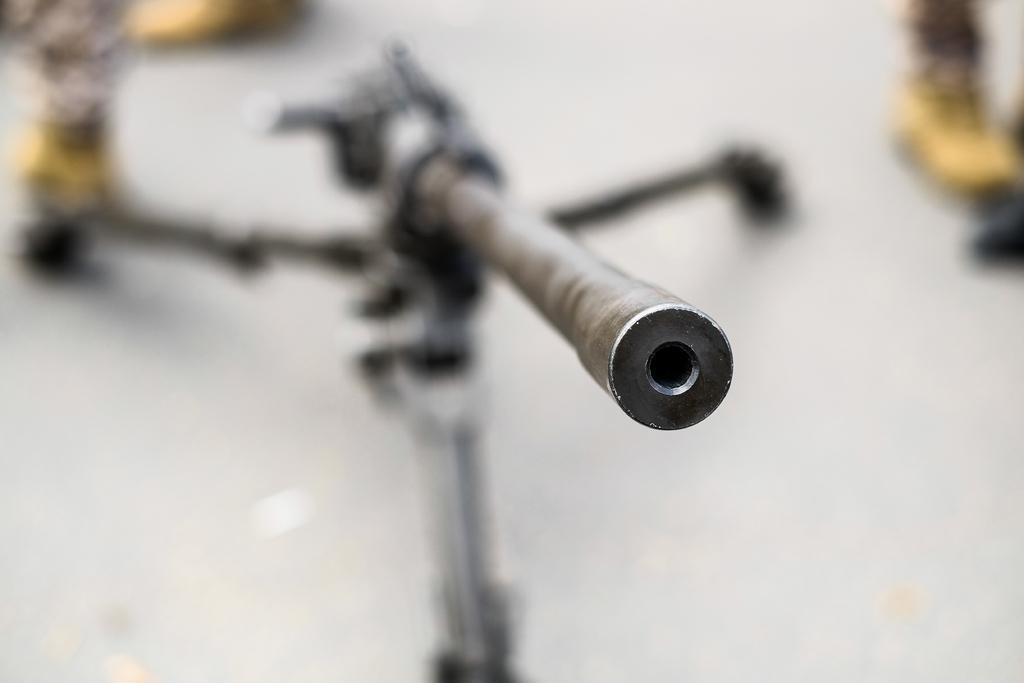Could you give a brief overview of what you see in this image? In the image we can see a camera stand and the background is blurred. 